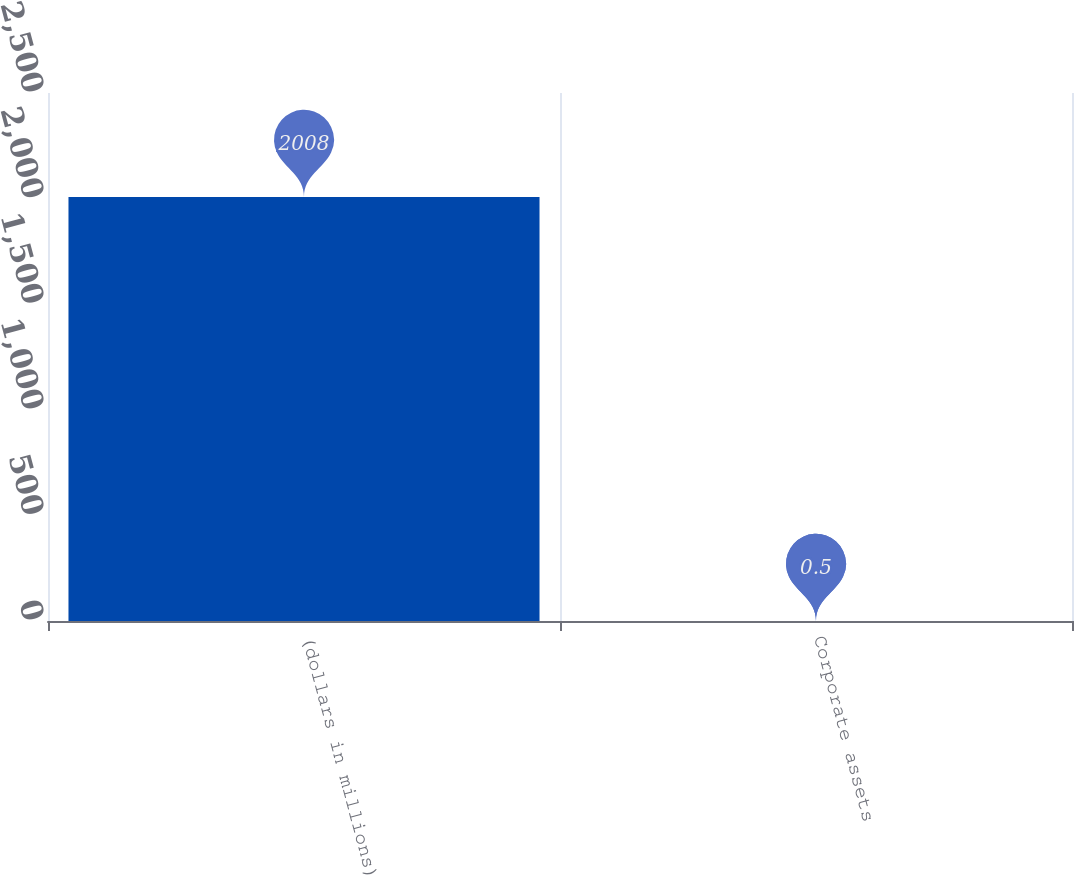Convert chart. <chart><loc_0><loc_0><loc_500><loc_500><bar_chart><fcel>(dollars in millions)<fcel>Corporate assets<nl><fcel>2008<fcel>0.5<nl></chart> 